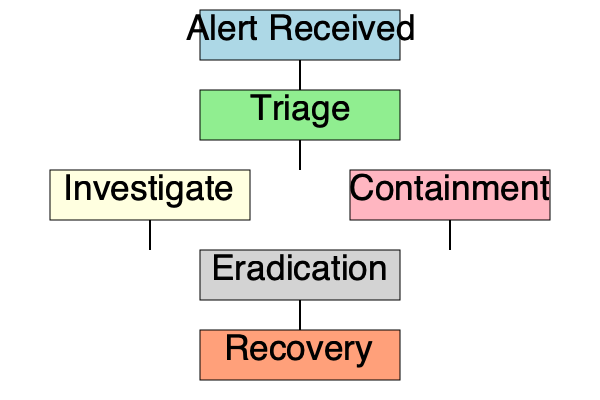In the security incident response workflow depicted in the flowchart, which step should be performed immediately after the "Triage" phase? The security incident response workflow illustrated in the flowchart follows these steps:

1. Alert Received: This is the initial stage where a security alert is detected or reported.

2. Triage: The alert is assessed to determine its severity and priority.

3. After the Triage phase, the workflow splits into two parallel paths:
   a. Investigate: This involves gathering more information about the incident, analyzing logs, and determining the scope of the breach.
   b. Containment: This step focuses on limiting the impact of the incident and preventing further damage.

4. Eradication: After investigation and containment, the threat is removed from the system.

5. Recovery: The final step involves restoring affected systems and returning to normal operations.

Based on the flowchart, immediately after the "Triage" phase, the process branches into two simultaneous steps: "Investigate" and "Containment". This parallel approach allows for a more efficient response, as the security team can gather information about the incident while also taking immediate action to limit its impact.
Answer: Investigate and Containment (in parallel) 